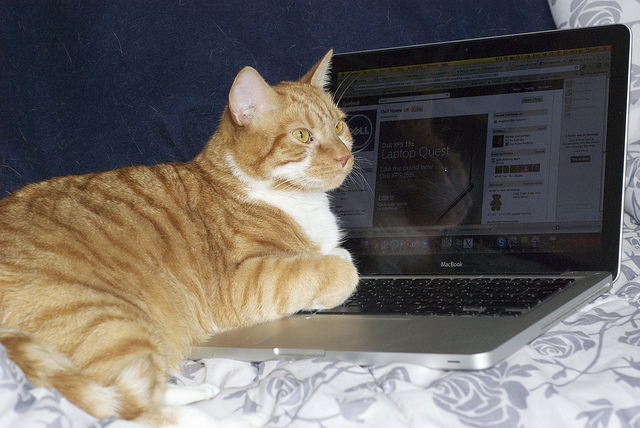Please transcribe the text in this image. DELL DELL DELL XPS Laptop QUEST Like the new DELL XPS 15z MacBook 